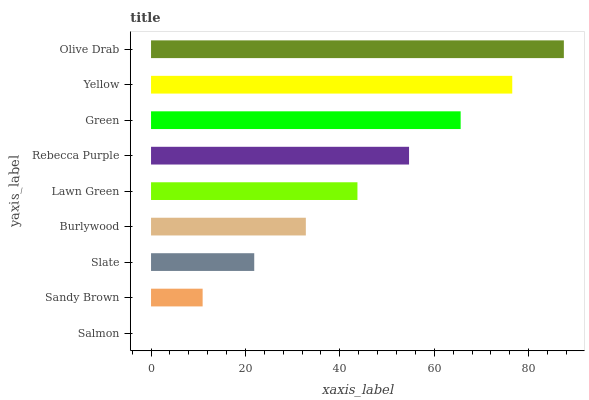Is Salmon the minimum?
Answer yes or no. Yes. Is Olive Drab the maximum?
Answer yes or no. Yes. Is Sandy Brown the minimum?
Answer yes or no. No. Is Sandy Brown the maximum?
Answer yes or no. No. Is Sandy Brown greater than Salmon?
Answer yes or no. Yes. Is Salmon less than Sandy Brown?
Answer yes or no. Yes. Is Salmon greater than Sandy Brown?
Answer yes or no. No. Is Sandy Brown less than Salmon?
Answer yes or no. No. Is Lawn Green the high median?
Answer yes or no. Yes. Is Lawn Green the low median?
Answer yes or no. Yes. Is Rebecca Purple the high median?
Answer yes or no. No. Is Green the low median?
Answer yes or no. No. 